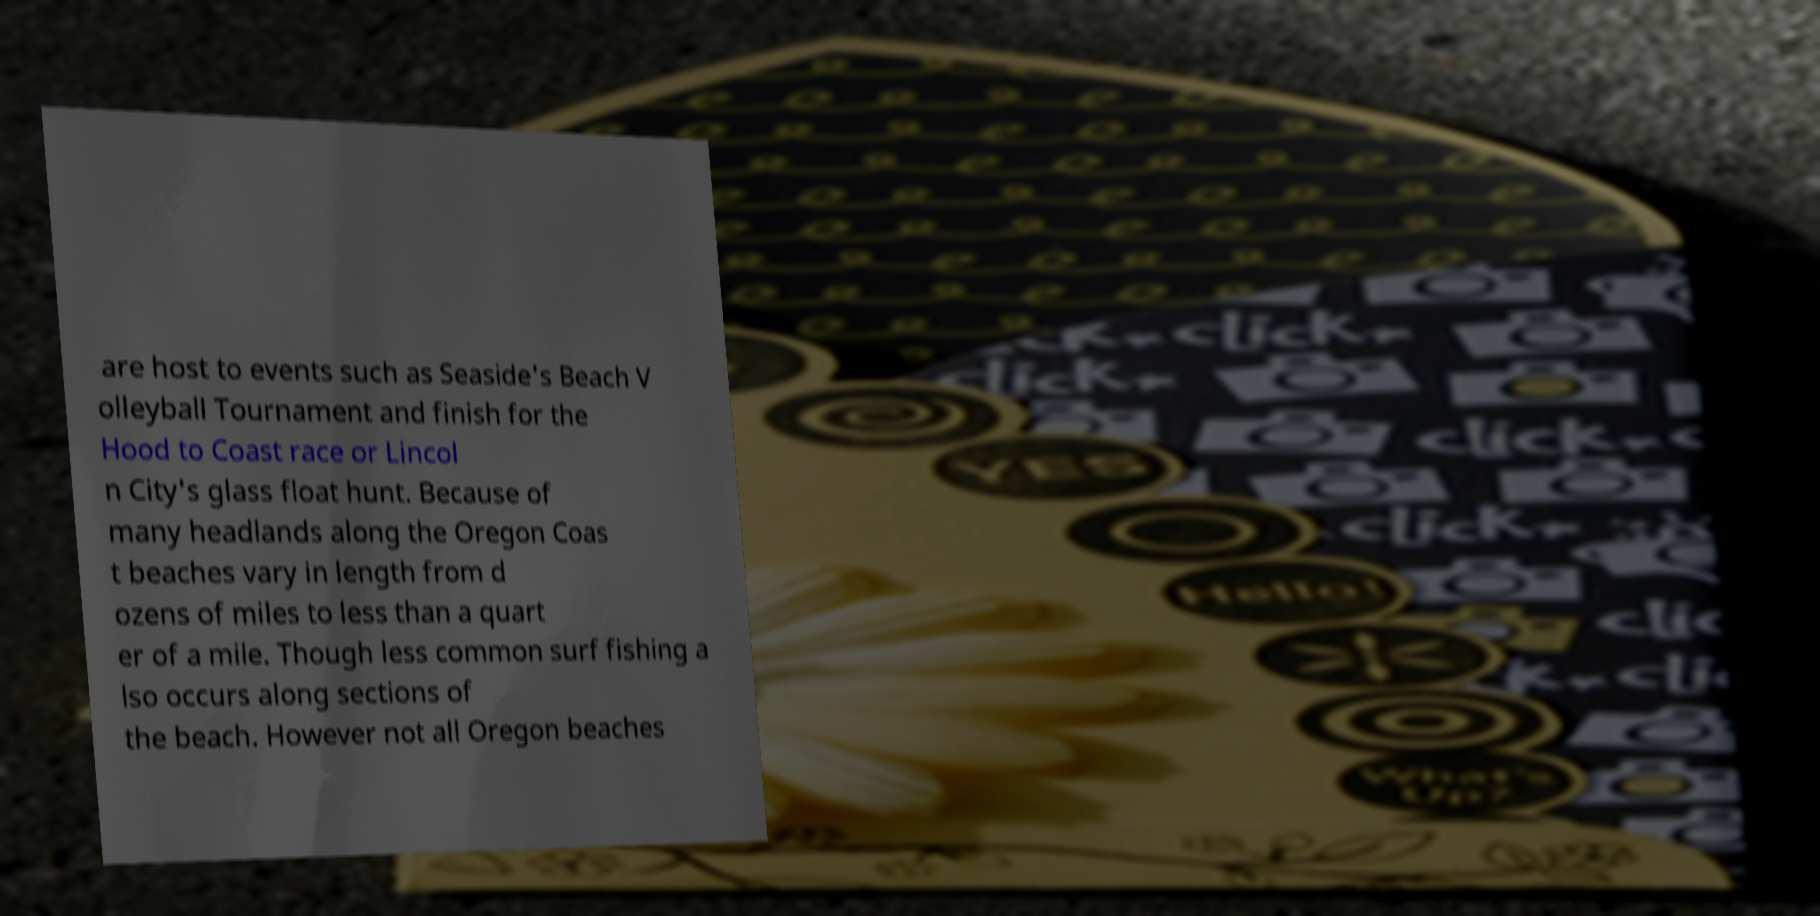Please identify and transcribe the text found in this image. are host to events such as Seaside's Beach V olleyball Tournament and finish for the Hood to Coast race or Lincol n City's glass float hunt. Because of many headlands along the Oregon Coas t beaches vary in length from d ozens of miles to less than a quart er of a mile. Though less common surf fishing a lso occurs along sections of the beach. However not all Oregon beaches 